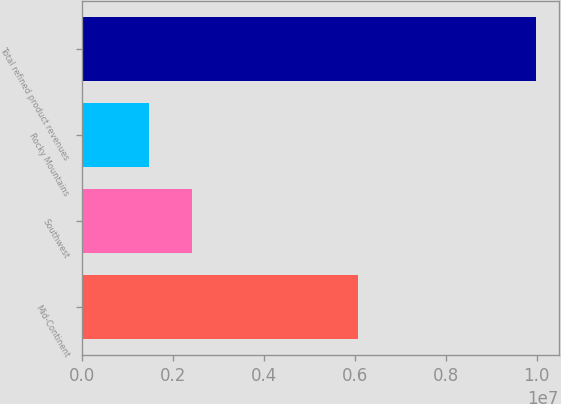<chart> <loc_0><loc_0><loc_500><loc_500><bar_chart><fcel>Mid-Continent<fcel>Southwest<fcel>Rocky Mountains<fcel>Total refined product revenues<nl><fcel>6.07763e+06<fcel>2.42576e+06<fcel>1.48181e+06<fcel>9.98521e+06<nl></chart> 